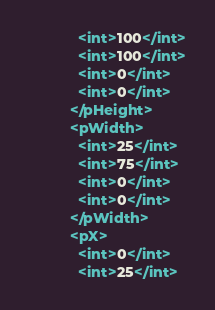Convert code to text. <code><loc_0><loc_0><loc_500><loc_500><_XML_>            <int>100</int>
            <int>100</int>
            <int>0</int>
            <int>0</int>
          </pHeight>
          <pWidth>
            <int>25</int>
            <int>75</int>
            <int>0</int>
            <int>0</int>
          </pWidth>
          <pX>
            <int>0</int>
            <int>25</int></code> 